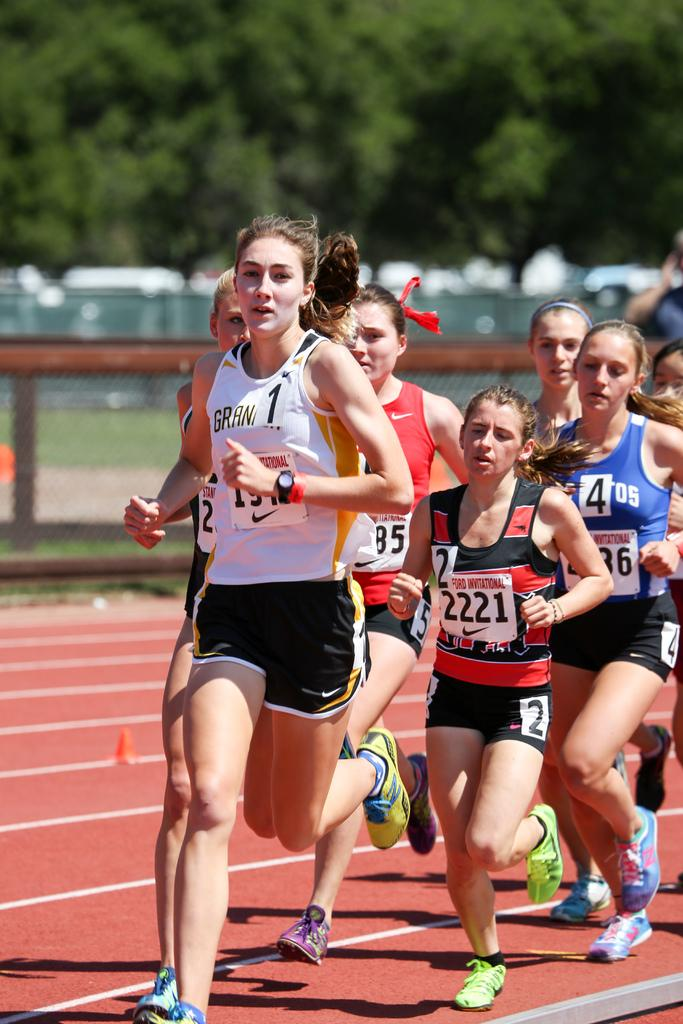<image>
Offer a succinct explanation of the picture presented. Girls running in the Ford Invitational race sponsored by Nike. 